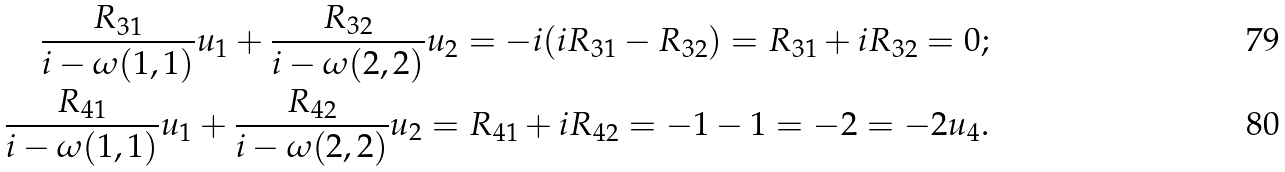Convert formula to latex. <formula><loc_0><loc_0><loc_500><loc_500>\frac { R _ { 3 1 } } { i - \omega ( 1 , 1 ) } u _ { 1 } + \frac { R _ { 3 2 } } { i - \omega ( 2 , 2 ) } u _ { 2 } = - i ( i R _ { 3 1 } - R _ { 3 2 } ) = R _ { 3 1 } + i R _ { 3 2 } = 0 ; \\ \frac { R _ { 4 1 } } { i - \omega ( 1 , 1 ) } u _ { 1 } + \frac { R _ { 4 2 } } { i - \omega ( 2 , 2 ) } u _ { 2 } = R _ { 4 1 } + i R _ { 4 2 } = - 1 - 1 = - 2 = - 2 u _ { 4 } .</formula> 